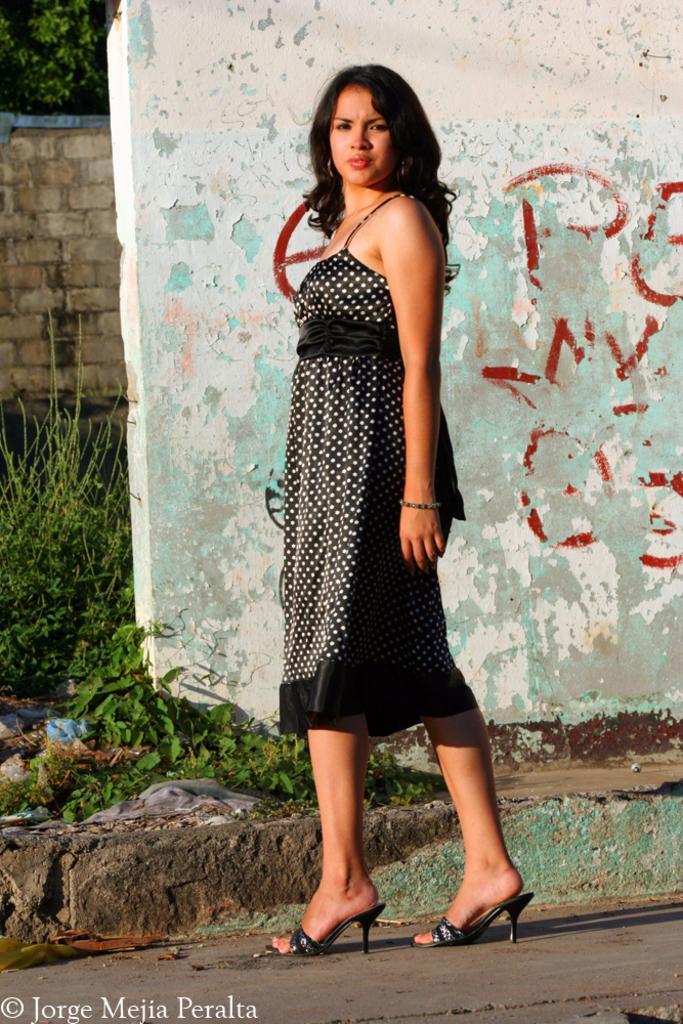Please provide a concise description of this image. In this picture, we can see a person, road, path, plants, trees, walls, we can see some water mark on the bottom left side of the picture. 